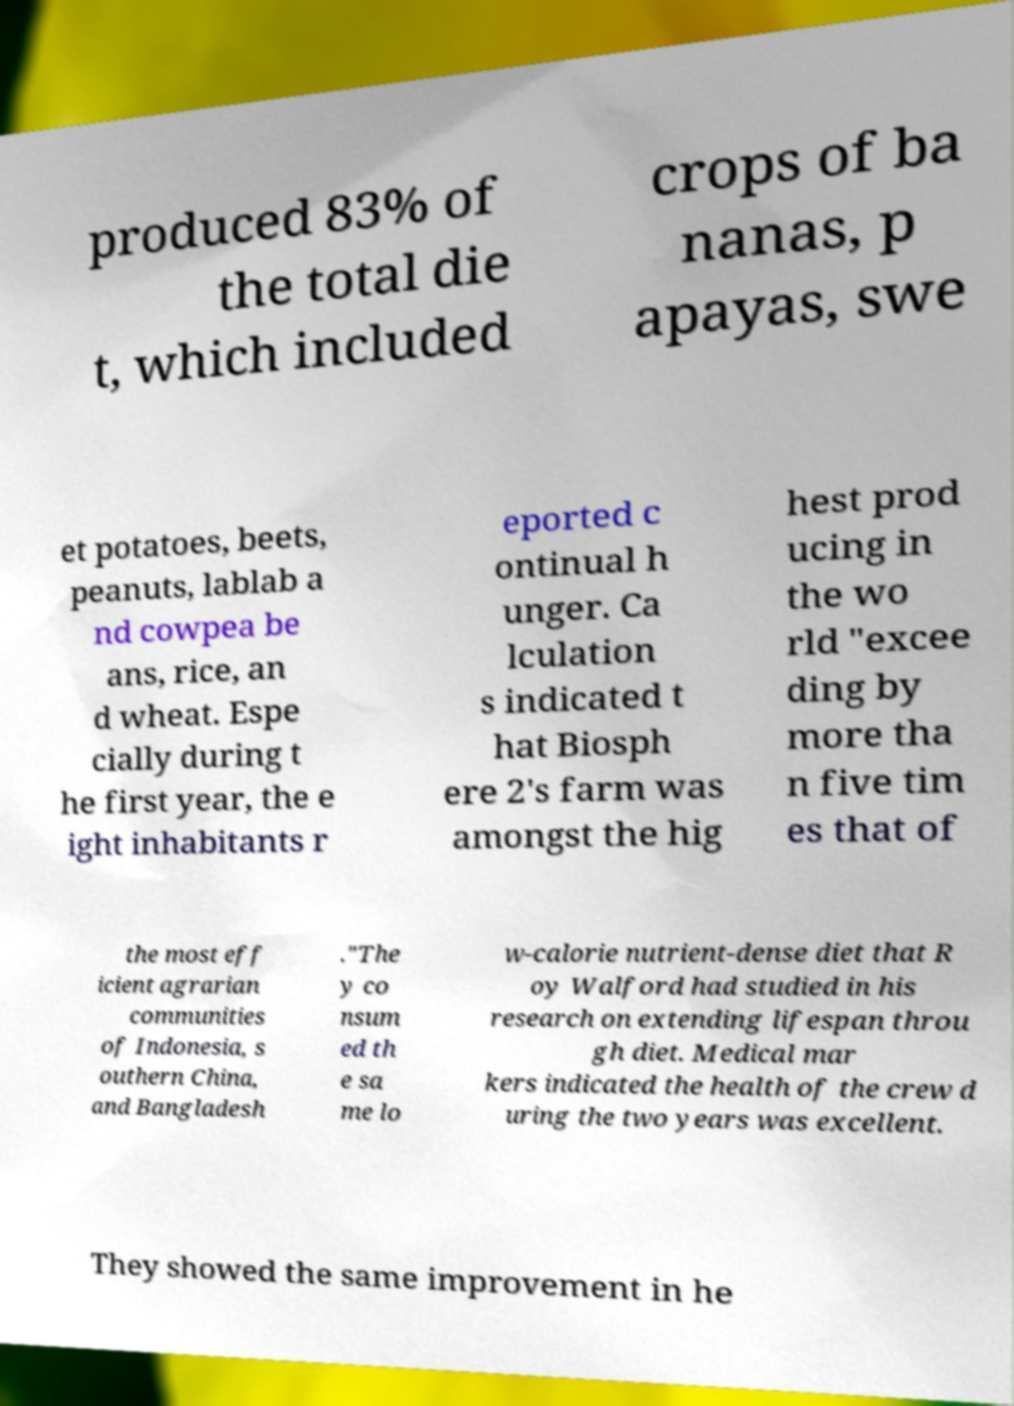Could you extract and type out the text from this image? produced 83% of the total die t, which included crops of ba nanas, p apayas, swe et potatoes, beets, peanuts, lablab a nd cowpea be ans, rice, an d wheat. Espe cially during t he first year, the e ight inhabitants r eported c ontinual h unger. Ca lculation s indicated t hat Biosph ere 2's farm was amongst the hig hest prod ucing in the wo rld "excee ding by more tha n five tim es that of the most eff icient agrarian communities of Indonesia, s outhern China, and Bangladesh ."The y co nsum ed th e sa me lo w-calorie nutrient-dense diet that R oy Walford had studied in his research on extending lifespan throu gh diet. Medical mar kers indicated the health of the crew d uring the two years was excellent. They showed the same improvement in he 